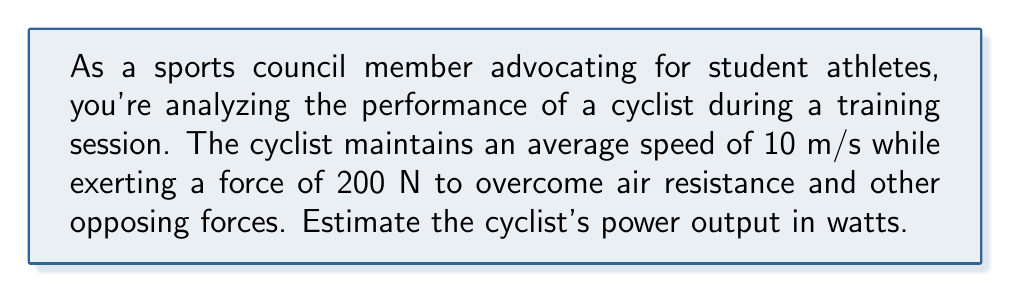Teach me how to tackle this problem. To solve this problem, we'll use the fundamental relationship between power, force, and velocity. The steps are as follows:

1) The power output (P) of the cyclist is given by the product of the force (F) applied and the velocity (v):

   $$P = F \cdot v$$

2) We are given:
   - Force (F) = 200 N
   - Velocity (v) = 10 m/s

3) Substituting these values into the equation:

   $$P = 200 \text{ N} \cdot 10 \text{ m/s}$$

4) Simplify:

   $$P = 2000 \text{ N} \cdot \text{m/s}$$

5) The unit N·m/s is equivalent to watts (W), so our final answer is:

   $$P = 2000 \text{ W}$$

This calculation provides an estimate of the cyclist's power output, which is crucial for assessing athletic performance and determining appropriate training regimens for student athletes.
Answer: 2000 W 